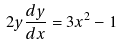Convert formula to latex. <formula><loc_0><loc_0><loc_500><loc_500>2 y \frac { d y } { d x } = 3 x ^ { 2 } - 1</formula> 